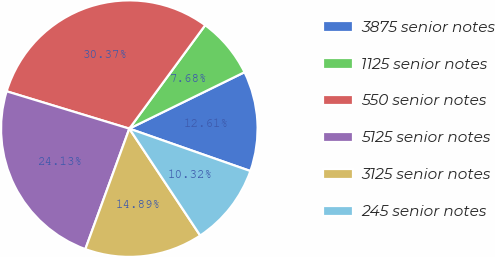Convert chart to OTSL. <chart><loc_0><loc_0><loc_500><loc_500><pie_chart><fcel>3875 senior notes<fcel>1125 senior notes<fcel>550 senior notes<fcel>5125 senior notes<fcel>3125 senior notes<fcel>245 senior notes<nl><fcel>12.61%<fcel>7.68%<fcel>30.37%<fcel>24.13%<fcel>14.89%<fcel>10.32%<nl></chart> 